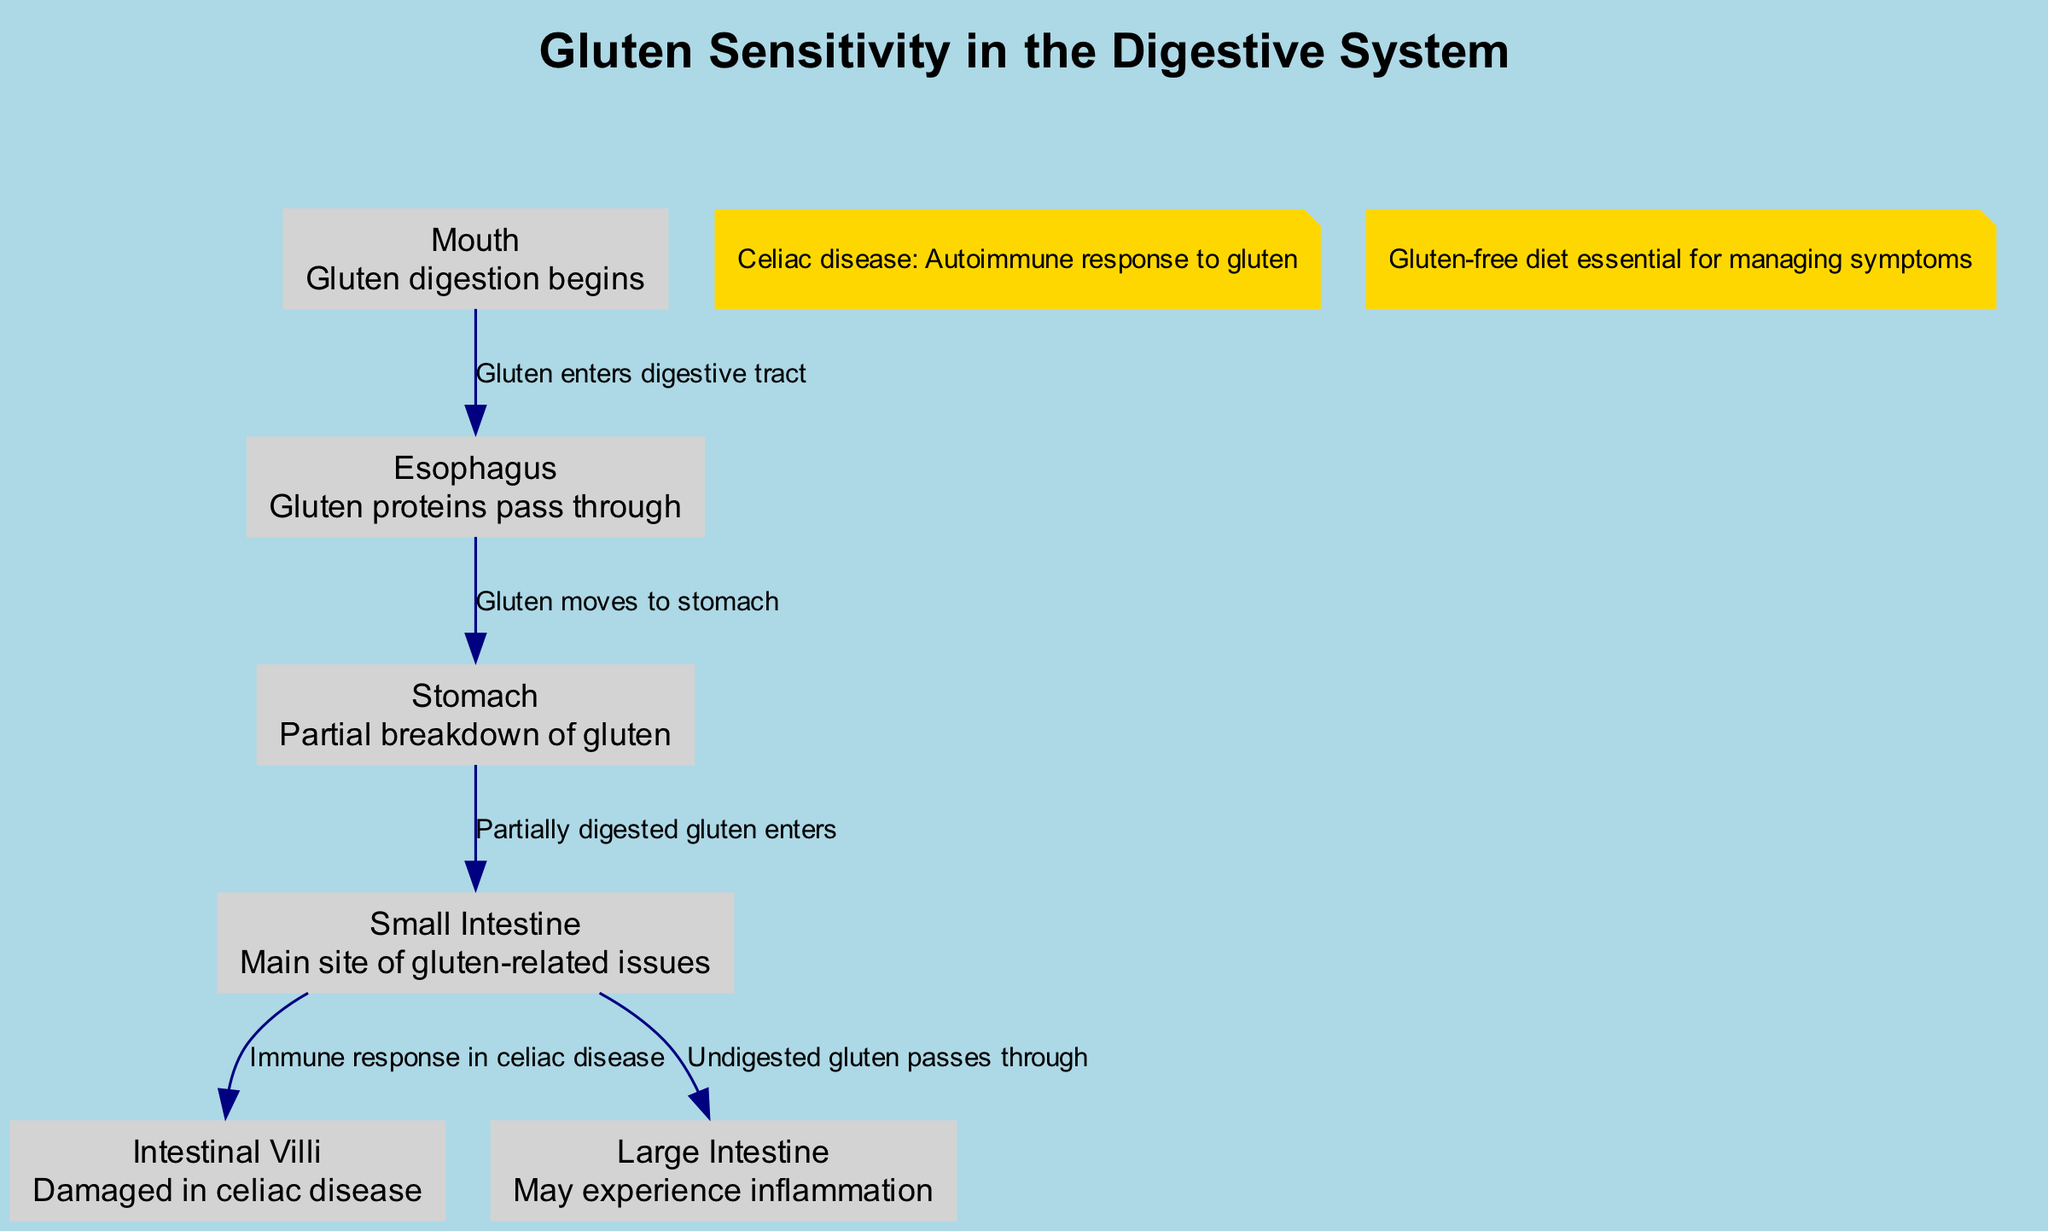What is the first organ where gluten digestion begins? According to the diagram, the first organ indicated for gluten digestion is the mouth, where gluten digestion starts.
Answer: Mouth Which organ is the main site of gluten-related issues? The small intestine is specifically labeled as the main site of gluten-related issues in the diagram, highlighting its importance in gluten sensitivity and celiac disease.
Answer: Small Intestine How many edges connect the mouth and the esophagus? The diagram shows a single edge that connects the mouth to the esophagus, indicating one direct pathway through which gluten enters the digestive tract.
Answer: 1 What immunological response occurs in the small intestine in celiac disease? The diagram indicates that the immune response occurs specifically in the intestinal villi when celiac disease is present, highlighting the effects of gluten sensitivity on the structure of intestinal health.
Answer: Immune response What dietary approach is essential for managing gluten sensitivity symptoms? The diagram notes that following a gluten-free diet is essential for managing symptoms related to gluten sensitivity and celiac disease, pointing towards dietary intervention as a key management strategy.
Answer: Gluten-free diet How are the large intestine and the small intestine connected in the digestive process? In the diagram, undigested gluten passes from the small intestine to the large intestine, establishing a clear connection and indicating a potential for inflammatory response in the large intestine as part of gluten sensitivity.
Answer: Undigested gluten passes through What is the key annotation that describes celiac disease? The annotation states that celiac disease involves an autoimmune response to gluten, providing a clear summary of its nature and implications for affected individuals.
Answer: Autoimmune response to gluten Which two organs are involved in the partial breakdown of gluten? The stomach and small intestine are involved in the digestive process, as the stomach performs a partial breakdown of gluten before it enters the small intestine for further digestion.
Answer: Stomach, Small Intestine How many nodes are represented in the diagram? The diagram includes six distinct nodes that represent different organs and structures involved in the digestion of gluten and the effects of gluten sensitivity.
Answer: 6 